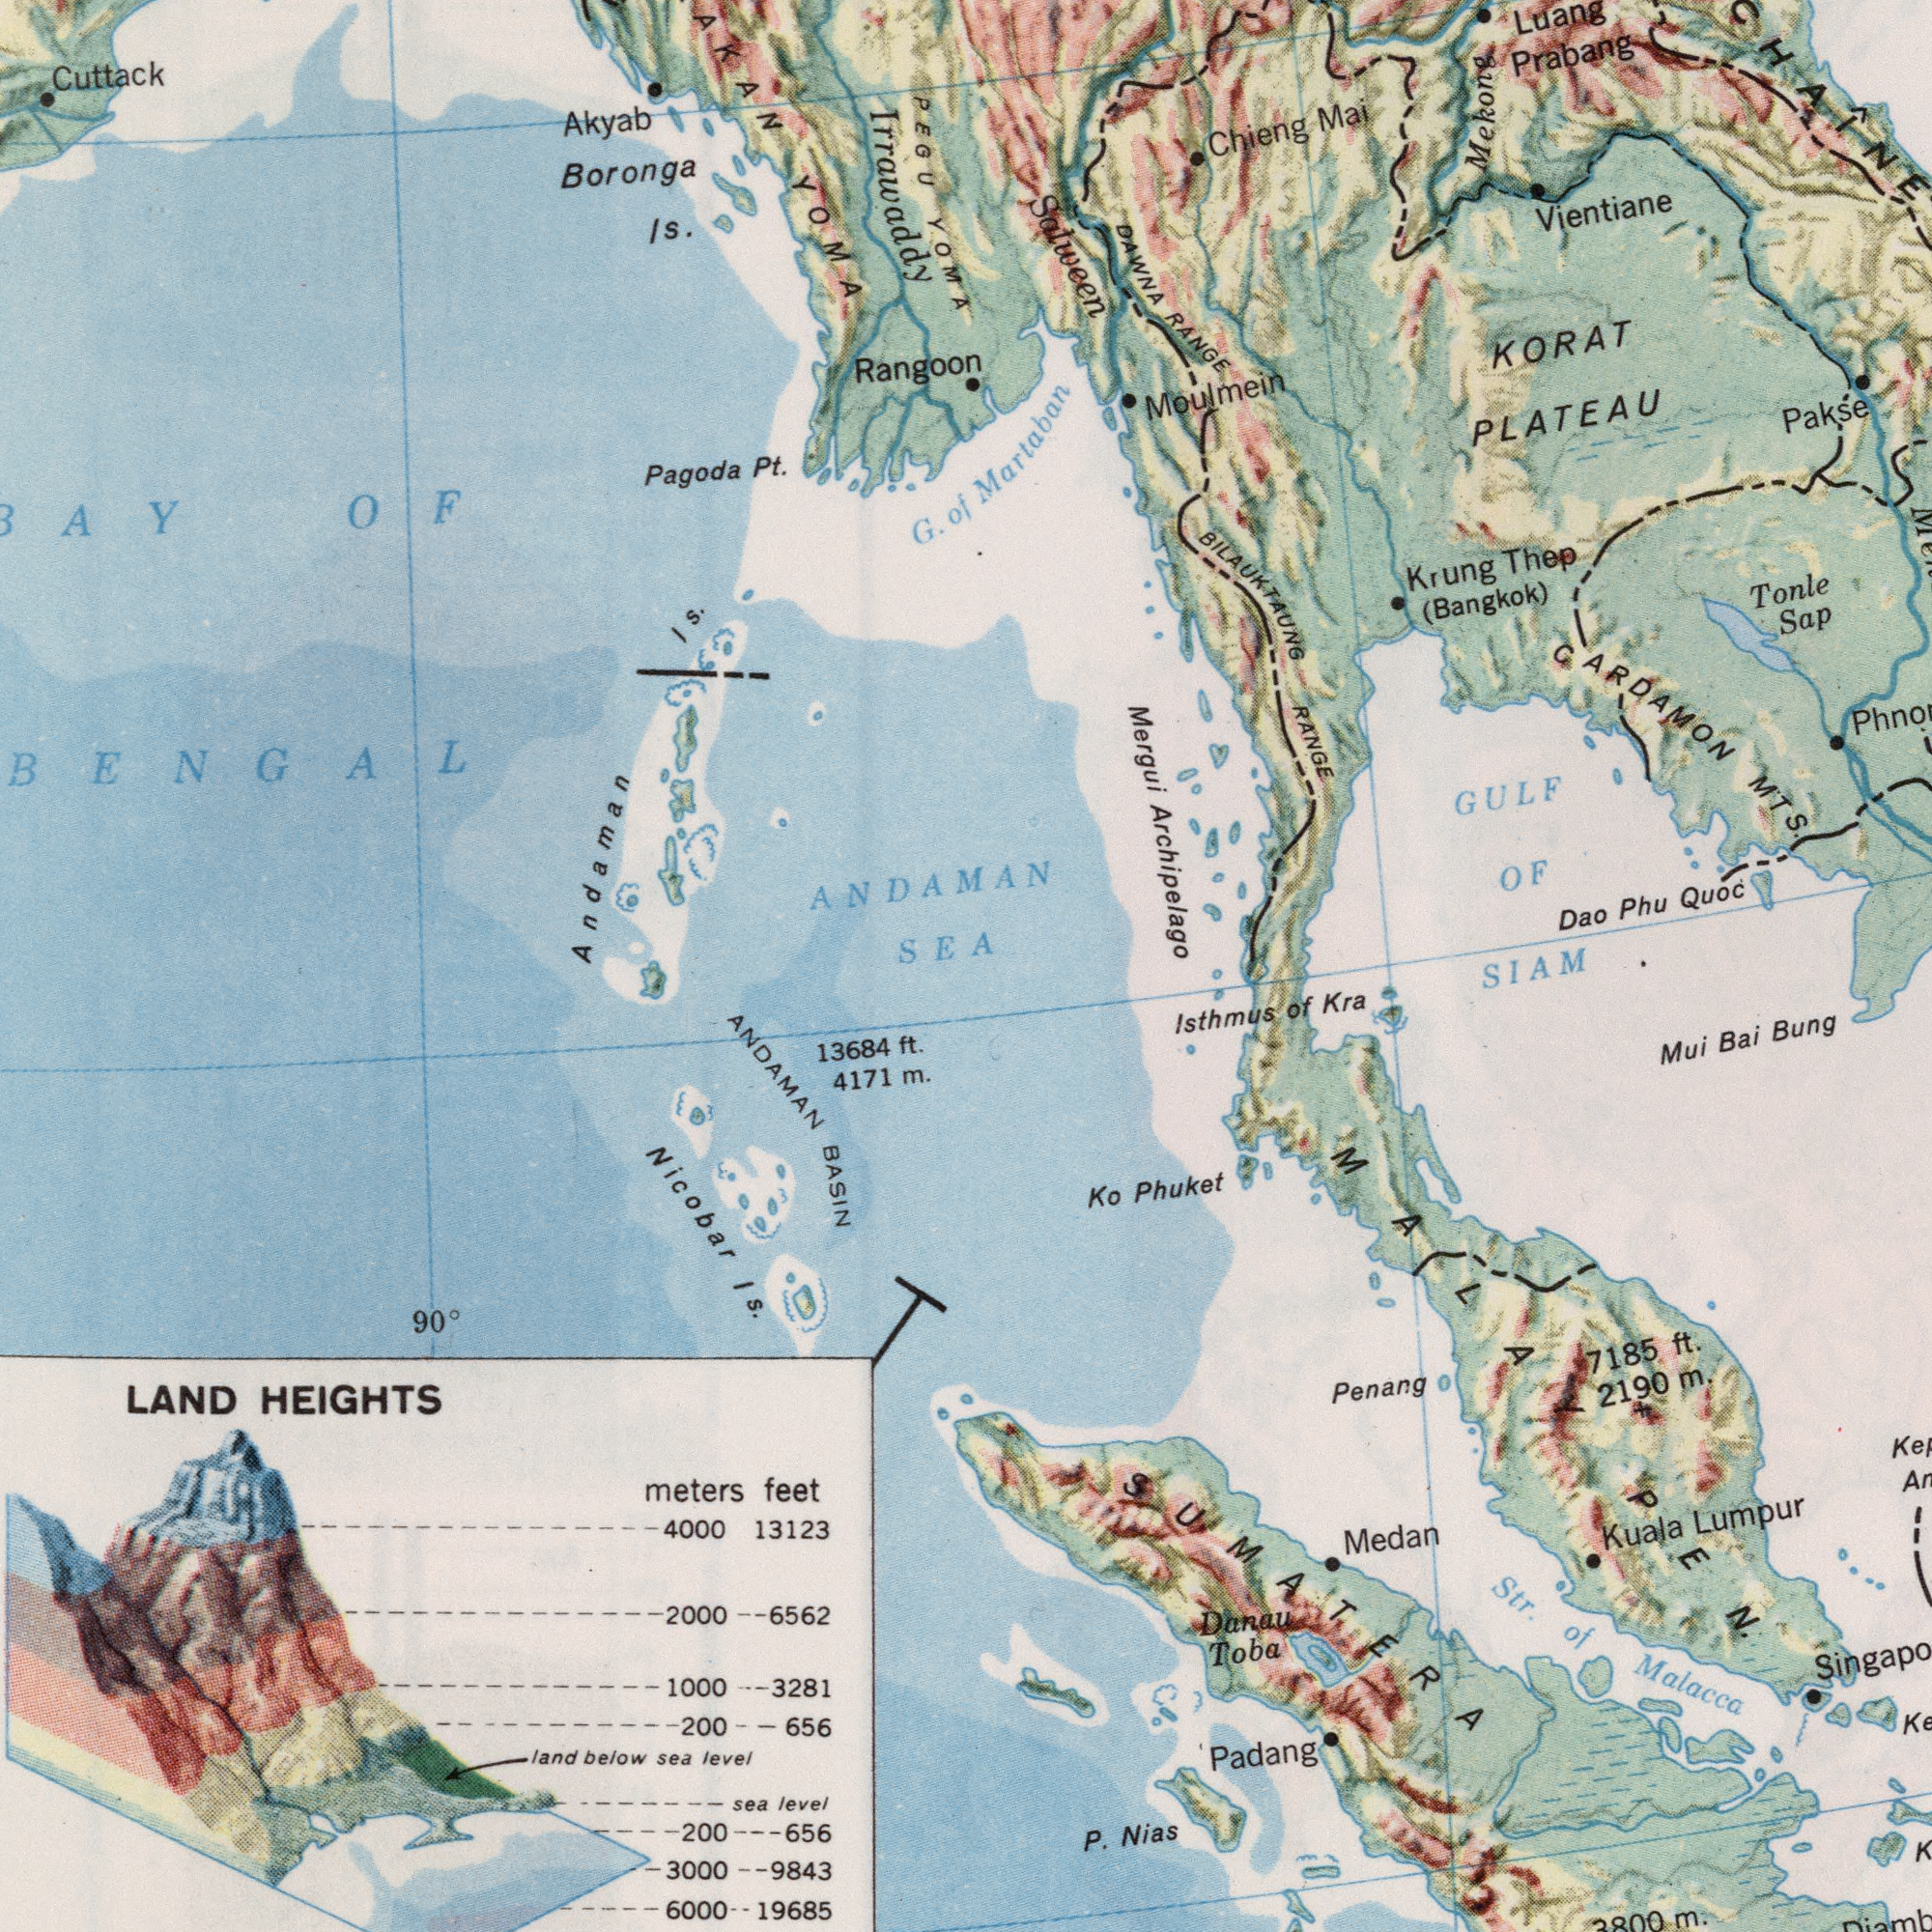What text is shown in the top-right quadrant? Martaban DAWNA RANGE Salween KORAT PLATEAU BILAUKTAUNG RANGE Moulmein Mergui Archipelago Luang Prabang Dao Phu Quoc Krung Thep (Bangkok) Vientiane CARDAMON MTS. GULF OF Pakse Tonle Sap Chieng Mai Mekong What text appears in the top-left area of the image? Cuttack Akyab Boronga Is. PEGU YOMA Irrawaddy Andaman Is. Pagoda Pt. G. of YOMA BAY OF BENGAL Rangoon ANDAMAN SEA What text can you see in the bottom-left section? ANDAMAN BASIN LAND HEIGHTS Nicobar Is. 13684 ft. T meters 19685 sea level 4171 m. 13123 land below sea level 3000 3281 6000 2000 4000 9843 feet 6562 1000 200 656 200 90° 656 What text appears in the bottom-right area of the image? SIAM Str. of Malacca Ko Phuket Mui Bai Bung Kuala Lumpur P. Nias Padang Penang 7185 ft. lsthmus of Kra Danau Toba 2190 m. Medan SUMATERA 3800 m. K MALAY PEN. 